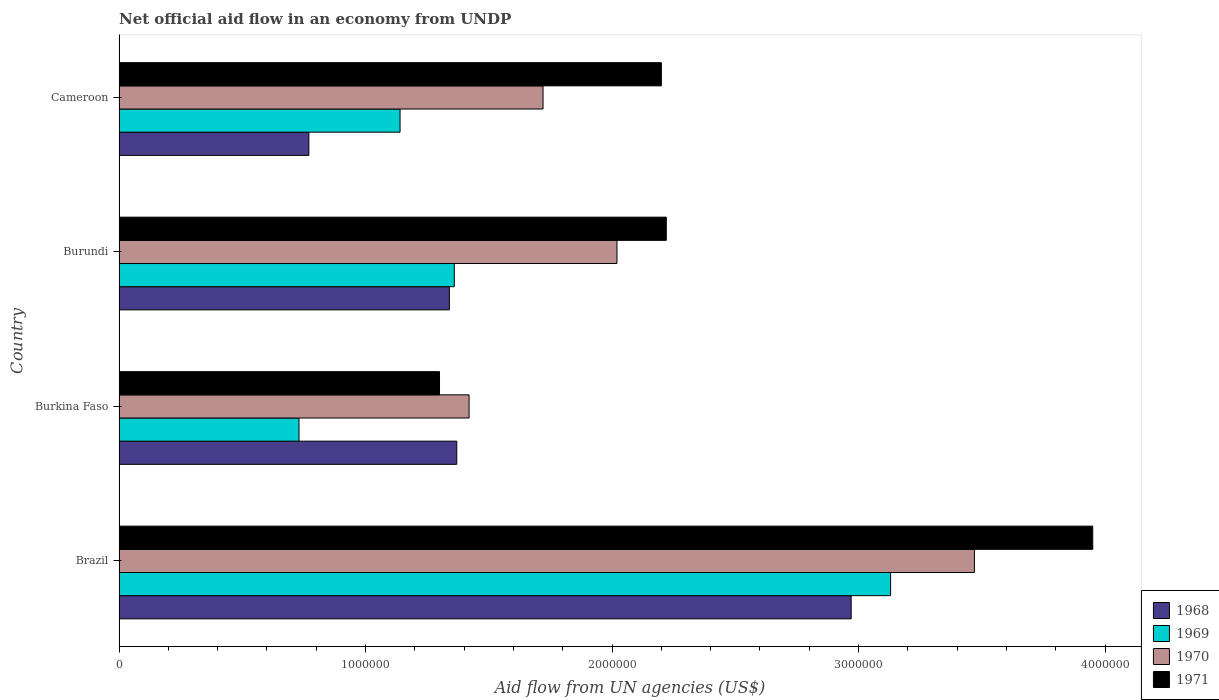How many different coloured bars are there?
Your response must be concise. 4. Are the number of bars on each tick of the Y-axis equal?
Ensure brevity in your answer.  Yes. How many bars are there on the 4th tick from the bottom?
Your answer should be compact. 4. What is the label of the 3rd group of bars from the top?
Provide a short and direct response. Burkina Faso. What is the net official aid flow in 1971 in Burundi?
Your response must be concise. 2.22e+06. Across all countries, what is the maximum net official aid flow in 1968?
Your response must be concise. 2.97e+06. Across all countries, what is the minimum net official aid flow in 1968?
Offer a very short reply. 7.70e+05. In which country was the net official aid flow in 1969 maximum?
Ensure brevity in your answer.  Brazil. In which country was the net official aid flow in 1969 minimum?
Keep it short and to the point. Burkina Faso. What is the total net official aid flow in 1970 in the graph?
Your answer should be compact. 8.63e+06. What is the difference between the net official aid flow in 1971 in Burkina Faso and that in Burundi?
Your answer should be compact. -9.20e+05. What is the average net official aid flow in 1969 per country?
Your answer should be compact. 1.59e+06. What is the difference between the net official aid flow in 1968 and net official aid flow in 1970 in Cameroon?
Provide a succinct answer. -9.50e+05. In how many countries, is the net official aid flow in 1969 greater than 2600000 US$?
Ensure brevity in your answer.  1. What is the ratio of the net official aid flow in 1968 in Brazil to that in Burkina Faso?
Your answer should be very brief. 2.17. Is the net official aid flow in 1969 in Brazil less than that in Burkina Faso?
Ensure brevity in your answer.  No. Is the difference between the net official aid flow in 1968 in Brazil and Burkina Faso greater than the difference between the net official aid flow in 1970 in Brazil and Burkina Faso?
Provide a short and direct response. No. What is the difference between the highest and the second highest net official aid flow in 1968?
Ensure brevity in your answer.  1.60e+06. What is the difference between the highest and the lowest net official aid flow in 1971?
Your answer should be very brief. 2.65e+06. What does the 3rd bar from the top in Cameroon represents?
Your answer should be compact. 1969. What does the 3rd bar from the bottom in Cameroon represents?
Provide a succinct answer. 1970. How many bars are there?
Offer a very short reply. 16. Are all the bars in the graph horizontal?
Your response must be concise. Yes. Does the graph contain any zero values?
Your answer should be very brief. No. Does the graph contain grids?
Provide a short and direct response. No. What is the title of the graph?
Provide a short and direct response. Net official aid flow in an economy from UNDP. Does "1971" appear as one of the legend labels in the graph?
Offer a terse response. Yes. What is the label or title of the X-axis?
Ensure brevity in your answer.  Aid flow from UN agencies (US$). What is the label or title of the Y-axis?
Keep it short and to the point. Country. What is the Aid flow from UN agencies (US$) in 1968 in Brazil?
Provide a succinct answer. 2.97e+06. What is the Aid flow from UN agencies (US$) in 1969 in Brazil?
Give a very brief answer. 3.13e+06. What is the Aid flow from UN agencies (US$) of 1970 in Brazil?
Provide a short and direct response. 3.47e+06. What is the Aid flow from UN agencies (US$) of 1971 in Brazil?
Keep it short and to the point. 3.95e+06. What is the Aid flow from UN agencies (US$) in 1968 in Burkina Faso?
Provide a succinct answer. 1.37e+06. What is the Aid flow from UN agencies (US$) in 1969 in Burkina Faso?
Offer a very short reply. 7.30e+05. What is the Aid flow from UN agencies (US$) in 1970 in Burkina Faso?
Provide a succinct answer. 1.42e+06. What is the Aid flow from UN agencies (US$) of 1971 in Burkina Faso?
Offer a terse response. 1.30e+06. What is the Aid flow from UN agencies (US$) in 1968 in Burundi?
Give a very brief answer. 1.34e+06. What is the Aid flow from UN agencies (US$) in 1969 in Burundi?
Ensure brevity in your answer.  1.36e+06. What is the Aid flow from UN agencies (US$) in 1970 in Burundi?
Your answer should be very brief. 2.02e+06. What is the Aid flow from UN agencies (US$) in 1971 in Burundi?
Keep it short and to the point. 2.22e+06. What is the Aid flow from UN agencies (US$) of 1968 in Cameroon?
Give a very brief answer. 7.70e+05. What is the Aid flow from UN agencies (US$) in 1969 in Cameroon?
Your response must be concise. 1.14e+06. What is the Aid flow from UN agencies (US$) in 1970 in Cameroon?
Provide a succinct answer. 1.72e+06. What is the Aid flow from UN agencies (US$) of 1971 in Cameroon?
Your response must be concise. 2.20e+06. Across all countries, what is the maximum Aid flow from UN agencies (US$) in 1968?
Give a very brief answer. 2.97e+06. Across all countries, what is the maximum Aid flow from UN agencies (US$) in 1969?
Keep it short and to the point. 3.13e+06. Across all countries, what is the maximum Aid flow from UN agencies (US$) in 1970?
Your answer should be compact. 3.47e+06. Across all countries, what is the maximum Aid flow from UN agencies (US$) in 1971?
Keep it short and to the point. 3.95e+06. Across all countries, what is the minimum Aid flow from UN agencies (US$) in 1968?
Your answer should be very brief. 7.70e+05. Across all countries, what is the minimum Aid flow from UN agencies (US$) in 1969?
Your response must be concise. 7.30e+05. Across all countries, what is the minimum Aid flow from UN agencies (US$) in 1970?
Offer a terse response. 1.42e+06. Across all countries, what is the minimum Aid flow from UN agencies (US$) in 1971?
Give a very brief answer. 1.30e+06. What is the total Aid flow from UN agencies (US$) of 1968 in the graph?
Ensure brevity in your answer.  6.45e+06. What is the total Aid flow from UN agencies (US$) of 1969 in the graph?
Offer a terse response. 6.36e+06. What is the total Aid flow from UN agencies (US$) in 1970 in the graph?
Ensure brevity in your answer.  8.63e+06. What is the total Aid flow from UN agencies (US$) in 1971 in the graph?
Your answer should be very brief. 9.67e+06. What is the difference between the Aid flow from UN agencies (US$) of 1968 in Brazil and that in Burkina Faso?
Provide a succinct answer. 1.60e+06. What is the difference between the Aid flow from UN agencies (US$) of 1969 in Brazil and that in Burkina Faso?
Your answer should be very brief. 2.40e+06. What is the difference between the Aid flow from UN agencies (US$) in 1970 in Brazil and that in Burkina Faso?
Make the answer very short. 2.05e+06. What is the difference between the Aid flow from UN agencies (US$) of 1971 in Brazil and that in Burkina Faso?
Ensure brevity in your answer.  2.65e+06. What is the difference between the Aid flow from UN agencies (US$) of 1968 in Brazil and that in Burundi?
Keep it short and to the point. 1.63e+06. What is the difference between the Aid flow from UN agencies (US$) in 1969 in Brazil and that in Burundi?
Make the answer very short. 1.77e+06. What is the difference between the Aid flow from UN agencies (US$) in 1970 in Brazil and that in Burundi?
Provide a short and direct response. 1.45e+06. What is the difference between the Aid flow from UN agencies (US$) in 1971 in Brazil and that in Burundi?
Give a very brief answer. 1.73e+06. What is the difference between the Aid flow from UN agencies (US$) in 1968 in Brazil and that in Cameroon?
Offer a terse response. 2.20e+06. What is the difference between the Aid flow from UN agencies (US$) in 1969 in Brazil and that in Cameroon?
Offer a terse response. 1.99e+06. What is the difference between the Aid flow from UN agencies (US$) in 1970 in Brazil and that in Cameroon?
Provide a short and direct response. 1.75e+06. What is the difference between the Aid flow from UN agencies (US$) of 1971 in Brazil and that in Cameroon?
Provide a short and direct response. 1.75e+06. What is the difference between the Aid flow from UN agencies (US$) of 1969 in Burkina Faso and that in Burundi?
Your answer should be compact. -6.30e+05. What is the difference between the Aid flow from UN agencies (US$) of 1970 in Burkina Faso and that in Burundi?
Ensure brevity in your answer.  -6.00e+05. What is the difference between the Aid flow from UN agencies (US$) of 1971 in Burkina Faso and that in Burundi?
Provide a short and direct response. -9.20e+05. What is the difference between the Aid flow from UN agencies (US$) of 1968 in Burkina Faso and that in Cameroon?
Make the answer very short. 6.00e+05. What is the difference between the Aid flow from UN agencies (US$) in 1969 in Burkina Faso and that in Cameroon?
Your answer should be compact. -4.10e+05. What is the difference between the Aid flow from UN agencies (US$) of 1971 in Burkina Faso and that in Cameroon?
Provide a succinct answer. -9.00e+05. What is the difference between the Aid flow from UN agencies (US$) in 1968 in Burundi and that in Cameroon?
Make the answer very short. 5.70e+05. What is the difference between the Aid flow from UN agencies (US$) of 1969 in Burundi and that in Cameroon?
Your response must be concise. 2.20e+05. What is the difference between the Aid flow from UN agencies (US$) of 1968 in Brazil and the Aid flow from UN agencies (US$) of 1969 in Burkina Faso?
Provide a short and direct response. 2.24e+06. What is the difference between the Aid flow from UN agencies (US$) of 1968 in Brazil and the Aid flow from UN agencies (US$) of 1970 in Burkina Faso?
Provide a succinct answer. 1.55e+06. What is the difference between the Aid flow from UN agencies (US$) in 1968 in Brazil and the Aid flow from UN agencies (US$) in 1971 in Burkina Faso?
Give a very brief answer. 1.67e+06. What is the difference between the Aid flow from UN agencies (US$) in 1969 in Brazil and the Aid flow from UN agencies (US$) in 1970 in Burkina Faso?
Offer a terse response. 1.71e+06. What is the difference between the Aid flow from UN agencies (US$) of 1969 in Brazil and the Aid flow from UN agencies (US$) of 1971 in Burkina Faso?
Your answer should be very brief. 1.83e+06. What is the difference between the Aid flow from UN agencies (US$) in 1970 in Brazil and the Aid flow from UN agencies (US$) in 1971 in Burkina Faso?
Provide a short and direct response. 2.17e+06. What is the difference between the Aid flow from UN agencies (US$) of 1968 in Brazil and the Aid flow from UN agencies (US$) of 1969 in Burundi?
Provide a short and direct response. 1.61e+06. What is the difference between the Aid flow from UN agencies (US$) in 1968 in Brazil and the Aid flow from UN agencies (US$) in 1970 in Burundi?
Your response must be concise. 9.50e+05. What is the difference between the Aid flow from UN agencies (US$) in 1968 in Brazil and the Aid flow from UN agencies (US$) in 1971 in Burundi?
Offer a very short reply. 7.50e+05. What is the difference between the Aid flow from UN agencies (US$) in 1969 in Brazil and the Aid flow from UN agencies (US$) in 1970 in Burundi?
Provide a short and direct response. 1.11e+06. What is the difference between the Aid flow from UN agencies (US$) in 1969 in Brazil and the Aid flow from UN agencies (US$) in 1971 in Burundi?
Offer a terse response. 9.10e+05. What is the difference between the Aid flow from UN agencies (US$) in 1970 in Brazil and the Aid flow from UN agencies (US$) in 1971 in Burundi?
Your answer should be compact. 1.25e+06. What is the difference between the Aid flow from UN agencies (US$) of 1968 in Brazil and the Aid flow from UN agencies (US$) of 1969 in Cameroon?
Make the answer very short. 1.83e+06. What is the difference between the Aid flow from UN agencies (US$) of 1968 in Brazil and the Aid flow from UN agencies (US$) of 1970 in Cameroon?
Keep it short and to the point. 1.25e+06. What is the difference between the Aid flow from UN agencies (US$) in 1968 in Brazil and the Aid flow from UN agencies (US$) in 1971 in Cameroon?
Ensure brevity in your answer.  7.70e+05. What is the difference between the Aid flow from UN agencies (US$) of 1969 in Brazil and the Aid flow from UN agencies (US$) of 1970 in Cameroon?
Make the answer very short. 1.41e+06. What is the difference between the Aid flow from UN agencies (US$) in 1969 in Brazil and the Aid flow from UN agencies (US$) in 1971 in Cameroon?
Your answer should be compact. 9.30e+05. What is the difference between the Aid flow from UN agencies (US$) in 1970 in Brazil and the Aid flow from UN agencies (US$) in 1971 in Cameroon?
Keep it short and to the point. 1.27e+06. What is the difference between the Aid flow from UN agencies (US$) in 1968 in Burkina Faso and the Aid flow from UN agencies (US$) in 1970 in Burundi?
Make the answer very short. -6.50e+05. What is the difference between the Aid flow from UN agencies (US$) in 1968 in Burkina Faso and the Aid flow from UN agencies (US$) in 1971 in Burundi?
Offer a terse response. -8.50e+05. What is the difference between the Aid flow from UN agencies (US$) of 1969 in Burkina Faso and the Aid flow from UN agencies (US$) of 1970 in Burundi?
Provide a succinct answer. -1.29e+06. What is the difference between the Aid flow from UN agencies (US$) in 1969 in Burkina Faso and the Aid flow from UN agencies (US$) in 1971 in Burundi?
Ensure brevity in your answer.  -1.49e+06. What is the difference between the Aid flow from UN agencies (US$) in 1970 in Burkina Faso and the Aid flow from UN agencies (US$) in 1971 in Burundi?
Give a very brief answer. -8.00e+05. What is the difference between the Aid flow from UN agencies (US$) of 1968 in Burkina Faso and the Aid flow from UN agencies (US$) of 1970 in Cameroon?
Offer a terse response. -3.50e+05. What is the difference between the Aid flow from UN agencies (US$) of 1968 in Burkina Faso and the Aid flow from UN agencies (US$) of 1971 in Cameroon?
Your answer should be very brief. -8.30e+05. What is the difference between the Aid flow from UN agencies (US$) of 1969 in Burkina Faso and the Aid flow from UN agencies (US$) of 1970 in Cameroon?
Your answer should be very brief. -9.90e+05. What is the difference between the Aid flow from UN agencies (US$) of 1969 in Burkina Faso and the Aid flow from UN agencies (US$) of 1971 in Cameroon?
Your answer should be compact. -1.47e+06. What is the difference between the Aid flow from UN agencies (US$) of 1970 in Burkina Faso and the Aid flow from UN agencies (US$) of 1971 in Cameroon?
Ensure brevity in your answer.  -7.80e+05. What is the difference between the Aid flow from UN agencies (US$) of 1968 in Burundi and the Aid flow from UN agencies (US$) of 1970 in Cameroon?
Make the answer very short. -3.80e+05. What is the difference between the Aid flow from UN agencies (US$) of 1968 in Burundi and the Aid flow from UN agencies (US$) of 1971 in Cameroon?
Keep it short and to the point. -8.60e+05. What is the difference between the Aid flow from UN agencies (US$) of 1969 in Burundi and the Aid flow from UN agencies (US$) of 1970 in Cameroon?
Offer a terse response. -3.60e+05. What is the difference between the Aid flow from UN agencies (US$) in 1969 in Burundi and the Aid flow from UN agencies (US$) in 1971 in Cameroon?
Keep it short and to the point. -8.40e+05. What is the average Aid flow from UN agencies (US$) of 1968 per country?
Give a very brief answer. 1.61e+06. What is the average Aid flow from UN agencies (US$) of 1969 per country?
Keep it short and to the point. 1.59e+06. What is the average Aid flow from UN agencies (US$) of 1970 per country?
Make the answer very short. 2.16e+06. What is the average Aid flow from UN agencies (US$) of 1971 per country?
Your answer should be very brief. 2.42e+06. What is the difference between the Aid flow from UN agencies (US$) in 1968 and Aid flow from UN agencies (US$) in 1969 in Brazil?
Your response must be concise. -1.60e+05. What is the difference between the Aid flow from UN agencies (US$) in 1968 and Aid flow from UN agencies (US$) in 1970 in Brazil?
Offer a terse response. -5.00e+05. What is the difference between the Aid flow from UN agencies (US$) of 1968 and Aid flow from UN agencies (US$) of 1971 in Brazil?
Your answer should be very brief. -9.80e+05. What is the difference between the Aid flow from UN agencies (US$) of 1969 and Aid flow from UN agencies (US$) of 1970 in Brazil?
Give a very brief answer. -3.40e+05. What is the difference between the Aid flow from UN agencies (US$) in 1969 and Aid flow from UN agencies (US$) in 1971 in Brazil?
Make the answer very short. -8.20e+05. What is the difference between the Aid flow from UN agencies (US$) of 1970 and Aid flow from UN agencies (US$) of 1971 in Brazil?
Your response must be concise. -4.80e+05. What is the difference between the Aid flow from UN agencies (US$) in 1968 and Aid flow from UN agencies (US$) in 1969 in Burkina Faso?
Provide a short and direct response. 6.40e+05. What is the difference between the Aid flow from UN agencies (US$) of 1969 and Aid flow from UN agencies (US$) of 1970 in Burkina Faso?
Keep it short and to the point. -6.90e+05. What is the difference between the Aid flow from UN agencies (US$) of 1969 and Aid flow from UN agencies (US$) of 1971 in Burkina Faso?
Provide a succinct answer. -5.70e+05. What is the difference between the Aid flow from UN agencies (US$) of 1968 and Aid flow from UN agencies (US$) of 1969 in Burundi?
Your response must be concise. -2.00e+04. What is the difference between the Aid flow from UN agencies (US$) of 1968 and Aid flow from UN agencies (US$) of 1970 in Burundi?
Your answer should be compact. -6.80e+05. What is the difference between the Aid flow from UN agencies (US$) in 1968 and Aid flow from UN agencies (US$) in 1971 in Burundi?
Offer a very short reply. -8.80e+05. What is the difference between the Aid flow from UN agencies (US$) in 1969 and Aid flow from UN agencies (US$) in 1970 in Burundi?
Make the answer very short. -6.60e+05. What is the difference between the Aid flow from UN agencies (US$) of 1969 and Aid flow from UN agencies (US$) of 1971 in Burundi?
Provide a short and direct response. -8.60e+05. What is the difference between the Aid flow from UN agencies (US$) of 1968 and Aid flow from UN agencies (US$) of 1969 in Cameroon?
Offer a terse response. -3.70e+05. What is the difference between the Aid flow from UN agencies (US$) of 1968 and Aid flow from UN agencies (US$) of 1970 in Cameroon?
Make the answer very short. -9.50e+05. What is the difference between the Aid flow from UN agencies (US$) of 1968 and Aid flow from UN agencies (US$) of 1971 in Cameroon?
Your response must be concise. -1.43e+06. What is the difference between the Aid flow from UN agencies (US$) in 1969 and Aid flow from UN agencies (US$) in 1970 in Cameroon?
Keep it short and to the point. -5.80e+05. What is the difference between the Aid flow from UN agencies (US$) of 1969 and Aid flow from UN agencies (US$) of 1971 in Cameroon?
Provide a short and direct response. -1.06e+06. What is the difference between the Aid flow from UN agencies (US$) in 1970 and Aid flow from UN agencies (US$) in 1971 in Cameroon?
Provide a short and direct response. -4.80e+05. What is the ratio of the Aid flow from UN agencies (US$) in 1968 in Brazil to that in Burkina Faso?
Keep it short and to the point. 2.17. What is the ratio of the Aid flow from UN agencies (US$) in 1969 in Brazil to that in Burkina Faso?
Your answer should be compact. 4.29. What is the ratio of the Aid flow from UN agencies (US$) of 1970 in Brazil to that in Burkina Faso?
Give a very brief answer. 2.44. What is the ratio of the Aid flow from UN agencies (US$) of 1971 in Brazil to that in Burkina Faso?
Your answer should be compact. 3.04. What is the ratio of the Aid flow from UN agencies (US$) in 1968 in Brazil to that in Burundi?
Provide a short and direct response. 2.22. What is the ratio of the Aid flow from UN agencies (US$) of 1969 in Brazil to that in Burundi?
Keep it short and to the point. 2.3. What is the ratio of the Aid flow from UN agencies (US$) of 1970 in Brazil to that in Burundi?
Provide a succinct answer. 1.72. What is the ratio of the Aid flow from UN agencies (US$) in 1971 in Brazil to that in Burundi?
Keep it short and to the point. 1.78. What is the ratio of the Aid flow from UN agencies (US$) of 1968 in Brazil to that in Cameroon?
Your response must be concise. 3.86. What is the ratio of the Aid flow from UN agencies (US$) in 1969 in Brazil to that in Cameroon?
Make the answer very short. 2.75. What is the ratio of the Aid flow from UN agencies (US$) of 1970 in Brazil to that in Cameroon?
Keep it short and to the point. 2.02. What is the ratio of the Aid flow from UN agencies (US$) in 1971 in Brazil to that in Cameroon?
Give a very brief answer. 1.8. What is the ratio of the Aid flow from UN agencies (US$) of 1968 in Burkina Faso to that in Burundi?
Make the answer very short. 1.02. What is the ratio of the Aid flow from UN agencies (US$) in 1969 in Burkina Faso to that in Burundi?
Your answer should be compact. 0.54. What is the ratio of the Aid flow from UN agencies (US$) in 1970 in Burkina Faso to that in Burundi?
Keep it short and to the point. 0.7. What is the ratio of the Aid flow from UN agencies (US$) in 1971 in Burkina Faso to that in Burundi?
Provide a succinct answer. 0.59. What is the ratio of the Aid flow from UN agencies (US$) in 1968 in Burkina Faso to that in Cameroon?
Offer a terse response. 1.78. What is the ratio of the Aid flow from UN agencies (US$) in 1969 in Burkina Faso to that in Cameroon?
Offer a very short reply. 0.64. What is the ratio of the Aid flow from UN agencies (US$) in 1970 in Burkina Faso to that in Cameroon?
Offer a very short reply. 0.83. What is the ratio of the Aid flow from UN agencies (US$) of 1971 in Burkina Faso to that in Cameroon?
Ensure brevity in your answer.  0.59. What is the ratio of the Aid flow from UN agencies (US$) in 1968 in Burundi to that in Cameroon?
Provide a short and direct response. 1.74. What is the ratio of the Aid flow from UN agencies (US$) in 1969 in Burundi to that in Cameroon?
Provide a short and direct response. 1.19. What is the ratio of the Aid flow from UN agencies (US$) in 1970 in Burundi to that in Cameroon?
Your response must be concise. 1.17. What is the ratio of the Aid flow from UN agencies (US$) in 1971 in Burundi to that in Cameroon?
Provide a succinct answer. 1.01. What is the difference between the highest and the second highest Aid flow from UN agencies (US$) in 1968?
Your answer should be compact. 1.60e+06. What is the difference between the highest and the second highest Aid flow from UN agencies (US$) in 1969?
Your answer should be compact. 1.77e+06. What is the difference between the highest and the second highest Aid flow from UN agencies (US$) of 1970?
Provide a short and direct response. 1.45e+06. What is the difference between the highest and the second highest Aid flow from UN agencies (US$) of 1971?
Make the answer very short. 1.73e+06. What is the difference between the highest and the lowest Aid flow from UN agencies (US$) of 1968?
Offer a terse response. 2.20e+06. What is the difference between the highest and the lowest Aid flow from UN agencies (US$) in 1969?
Your answer should be very brief. 2.40e+06. What is the difference between the highest and the lowest Aid flow from UN agencies (US$) of 1970?
Provide a short and direct response. 2.05e+06. What is the difference between the highest and the lowest Aid flow from UN agencies (US$) in 1971?
Provide a short and direct response. 2.65e+06. 